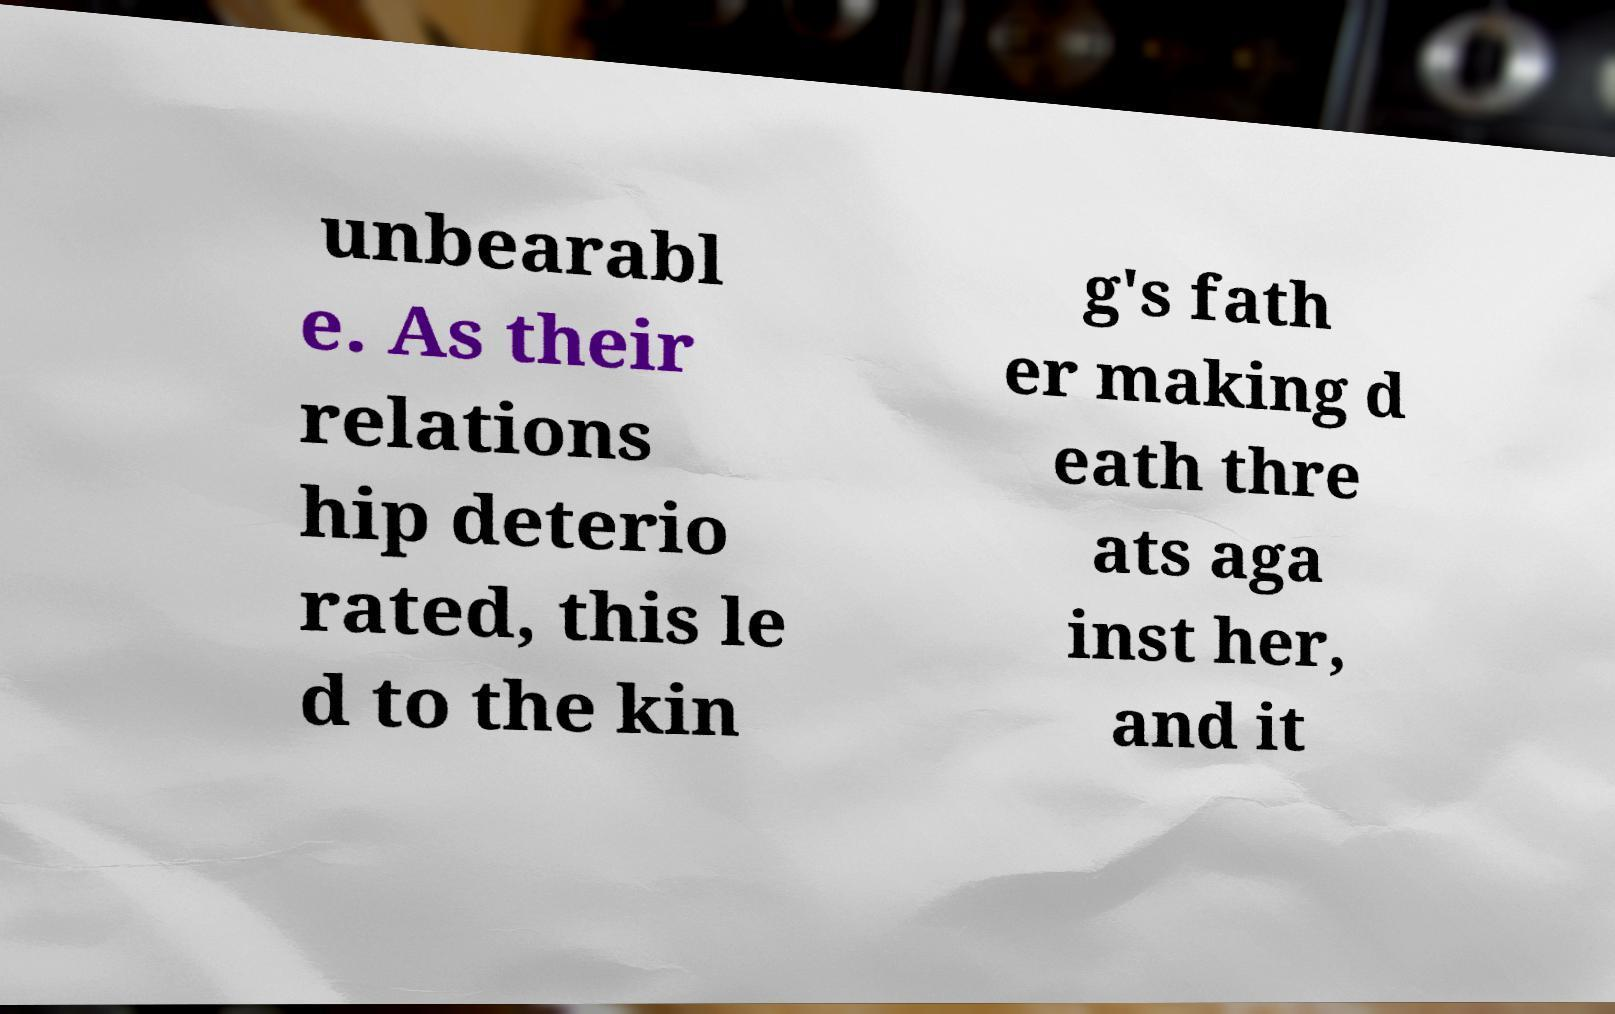Could you extract and type out the text from this image? unbearabl e. As their relations hip deterio rated, this le d to the kin g's fath er making d eath thre ats aga inst her, and it 